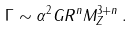Convert formula to latex. <formula><loc_0><loc_0><loc_500><loc_500>\Gamma \sim \alpha ^ { 2 } G R ^ { n } M _ { Z } ^ { 3 + n } \, .</formula> 